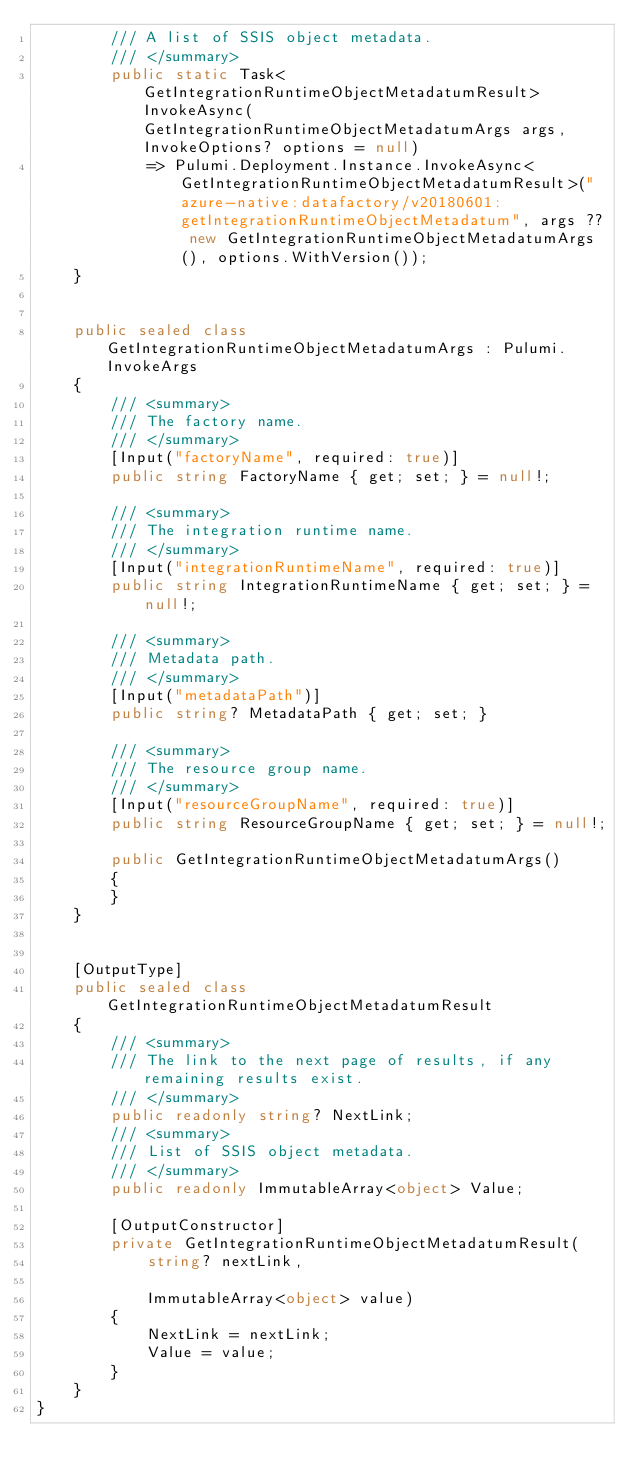<code> <loc_0><loc_0><loc_500><loc_500><_C#_>        /// A list of SSIS object metadata.
        /// </summary>
        public static Task<GetIntegrationRuntimeObjectMetadatumResult> InvokeAsync(GetIntegrationRuntimeObjectMetadatumArgs args, InvokeOptions? options = null)
            => Pulumi.Deployment.Instance.InvokeAsync<GetIntegrationRuntimeObjectMetadatumResult>("azure-native:datafactory/v20180601:getIntegrationRuntimeObjectMetadatum", args ?? new GetIntegrationRuntimeObjectMetadatumArgs(), options.WithVersion());
    }


    public sealed class GetIntegrationRuntimeObjectMetadatumArgs : Pulumi.InvokeArgs
    {
        /// <summary>
        /// The factory name.
        /// </summary>
        [Input("factoryName", required: true)]
        public string FactoryName { get; set; } = null!;

        /// <summary>
        /// The integration runtime name.
        /// </summary>
        [Input("integrationRuntimeName", required: true)]
        public string IntegrationRuntimeName { get; set; } = null!;

        /// <summary>
        /// Metadata path.
        /// </summary>
        [Input("metadataPath")]
        public string? MetadataPath { get; set; }

        /// <summary>
        /// The resource group name.
        /// </summary>
        [Input("resourceGroupName", required: true)]
        public string ResourceGroupName { get; set; } = null!;

        public GetIntegrationRuntimeObjectMetadatumArgs()
        {
        }
    }


    [OutputType]
    public sealed class GetIntegrationRuntimeObjectMetadatumResult
    {
        /// <summary>
        /// The link to the next page of results, if any remaining results exist.
        /// </summary>
        public readonly string? NextLink;
        /// <summary>
        /// List of SSIS object metadata.
        /// </summary>
        public readonly ImmutableArray<object> Value;

        [OutputConstructor]
        private GetIntegrationRuntimeObjectMetadatumResult(
            string? nextLink,

            ImmutableArray<object> value)
        {
            NextLink = nextLink;
            Value = value;
        }
    }
}
</code> 